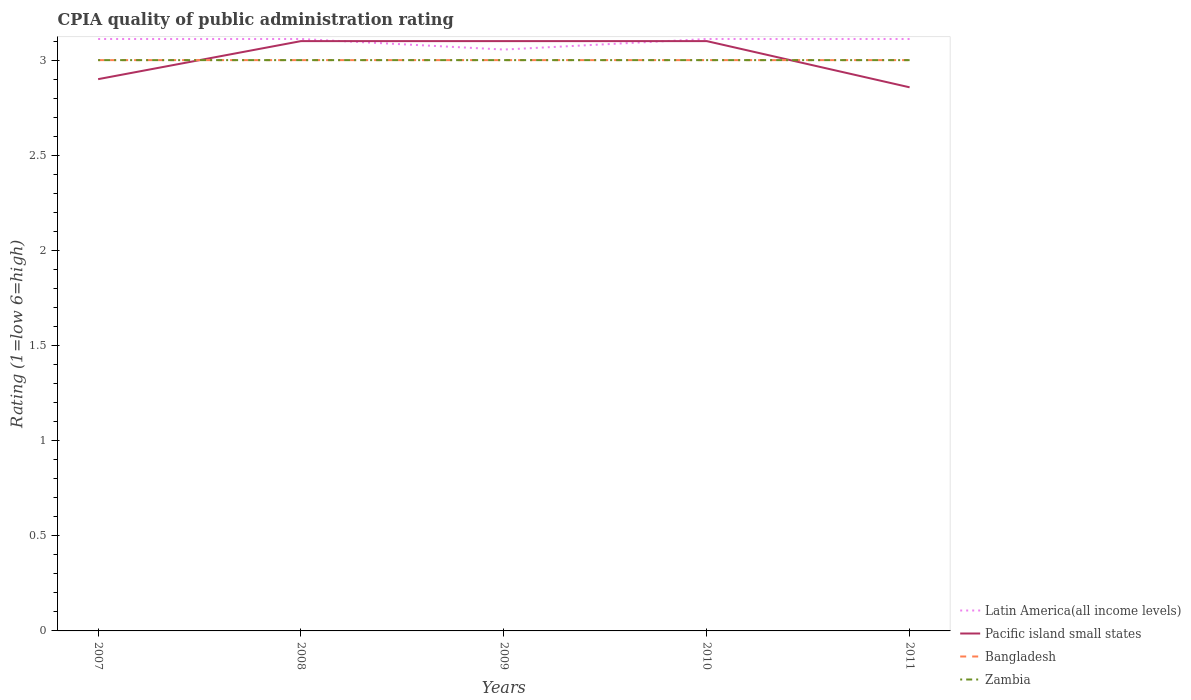How many different coloured lines are there?
Offer a very short reply. 4. Does the line corresponding to Pacific island small states intersect with the line corresponding to Latin America(all income levels)?
Provide a short and direct response. Yes. Across all years, what is the maximum CPIA rating in Latin America(all income levels)?
Give a very brief answer. 3.06. In which year was the CPIA rating in Zambia maximum?
Offer a very short reply. 2007. What is the difference between the highest and the lowest CPIA rating in Bangladesh?
Make the answer very short. 0. How many lines are there?
Offer a terse response. 4. How many years are there in the graph?
Your response must be concise. 5. What is the difference between two consecutive major ticks on the Y-axis?
Provide a short and direct response. 0.5. Does the graph contain any zero values?
Give a very brief answer. No. Does the graph contain grids?
Offer a very short reply. No. How many legend labels are there?
Ensure brevity in your answer.  4. What is the title of the graph?
Your answer should be compact. CPIA quality of public administration rating. Does "Zambia" appear as one of the legend labels in the graph?
Make the answer very short. Yes. What is the Rating (1=low 6=high) in Latin America(all income levels) in 2007?
Your answer should be very brief. 3.11. What is the Rating (1=low 6=high) of Pacific island small states in 2007?
Give a very brief answer. 2.9. What is the Rating (1=low 6=high) of Zambia in 2007?
Offer a very short reply. 3. What is the Rating (1=low 6=high) in Latin America(all income levels) in 2008?
Make the answer very short. 3.11. What is the Rating (1=low 6=high) of Latin America(all income levels) in 2009?
Give a very brief answer. 3.06. What is the Rating (1=low 6=high) in Pacific island small states in 2009?
Your response must be concise. 3.1. What is the Rating (1=low 6=high) of Bangladesh in 2009?
Provide a short and direct response. 3. What is the Rating (1=low 6=high) in Zambia in 2009?
Your answer should be compact. 3. What is the Rating (1=low 6=high) in Latin America(all income levels) in 2010?
Your response must be concise. 3.11. What is the Rating (1=low 6=high) of Bangladesh in 2010?
Give a very brief answer. 3. What is the Rating (1=low 6=high) in Zambia in 2010?
Your answer should be very brief. 3. What is the Rating (1=low 6=high) of Latin America(all income levels) in 2011?
Your answer should be very brief. 3.11. What is the Rating (1=low 6=high) of Pacific island small states in 2011?
Your answer should be very brief. 2.86. What is the Rating (1=low 6=high) in Bangladesh in 2011?
Your answer should be very brief. 3. What is the Rating (1=low 6=high) of Zambia in 2011?
Provide a short and direct response. 3. Across all years, what is the maximum Rating (1=low 6=high) in Latin America(all income levels)?
Provide a succinct answer. 3.11. Across all years, what is the maximum Rating (1=low 6=high) of Zambia?
Offer a terse response. 3. Across all years, what is the minimum Rating (1=low 6=high) in Latin America(all income levels)?
Your response must be concise. 3.06. Across all years, what is the minimum Rating (1=low 6=high) of Pacific island small states?
Provide a short and direct response. 2.86. What is the total Rating (1=low 6=high) of Pacific island small states in the graph?
Your answer should be compact. 15.06. What is the difference between the Rating (1=low 6=high) in Bangladesh in 2007 and that in 2008?
Your answer should be very brief. 0. What is the difference between the Rating (1=low 6=high) of Latin America(all income levels) in 2007 and that in 2009?
Your answer should be compact. 0.06. What is the difference between the Rating (1=low 6=high) of Pacific island small states in 2007 and that in 2009?
Give a very brief answer. -0.2. What is the difference between the Rating (1=low 6=high) of Bangladesh in 2007 and that in 2009?
Your response must be concise. 0. What is the difference between the Rating (1=low 6=high) of Latin America(all income levels) in 2007 and that in 2010?
Keep it short and to the point. 0. What is the difference between the Rating (1=low 6=high) of Pacific island small states in 2007 and that in 2010?
Keep it short and to the point. -0.2. What is the difference between the Rating (1=low 6=high) in Zambia in 2007 and that in 2010?
Ensure brevity in your answer.  0. What is the difference between the Rating (1=low 6=high) in Latin America(all income levels) in 2007 and that in 2011?
Your answer should be very brief. 0. What is the difference between the Rating (1=low 6=high) of Pacific island small states in 2007 and that in 2011?
Keep it short and to the point. 0.04. What is the difference between the Rating (1=low 6=high) in Zambia in 2007 and that in 2011?
Offer a terse response. 0. What is the difference between the Rating (1=low 6=high) in Latin America(all income levels) in 2008 and that in 2009?
Make the answer very short. 0.06. What is the difference between the Rating (1=low 6=high) in Pacific island small states in 2008 and that in 2009?
Keep it short and to the point. 0. What is the difference between the Rating (1=low 6=high) of Bangladesh in 2008 and that in 2009?
Your response must be concise. 0. What is the difference between the Rating (1=low 6=high) of Zambia in 2008 and that in 2010?
Your answer should be compact. 0. What is the difference between the Rating (1=low 6=high) of Pacific island small states in 2008 and that in 2011?
Give a very brief answer. 0.24. What is the difference between the Rating (1=low 6=high) of Latin America(all income levels) in 2009 and that in 2010?
Make the answer very short. -0.06. What is the difference between the Rating (1=low 6=high) in Zambia in 2009 and that in 2010?
Ensure brevity in your answer.  0. What is the difference between the Rating (1=low 6=high) of Latin America(all income levels) in 2009 and that in 2011?
Make the answer very short. -0.06. What is the difference between the Rating (1=low 6=high) of Pacific island small states in 2009 and that in 2011?
Offer a very short reply. 0.24. What is the difference between the Rating (1=low 6=high) in Pacific island small states in 2010 and that in 2011?
Provide a short and direct response. 0.24. What is the difference between the Rating (1=low 6=high) in Latin America(all income levels) in 2007 and the Rating (1=low 6=high) in Pacific island small states in 2008?
Your answer should be very brief. 0.01. What is the difference between the Rating (1=low 6=high) of Latin America(all income levels) in 2007 and the Rating (1=low 6=high) of Bangladesh in 2008?
Offer a very short reply. 0.11. What is the difference between the Rating (1=low 6=high) of Latin America(all income levels) in 2007 and the Rating (1=low 6=high) of Zambia in 2008?
Keep it short and to the point. 0.11. What is the difference between the Rating (1=low 6=high) of Pacific island small states in 2007 and the Rating (1=low 6=high) of Bangladesh in 2008?
Give a very brief answer. -0.1. What is the difference between the Rating (1=low 6=high) of Pacific island small states in 2007 and the Rating (1=low 6=high) of Zambia in 2008?
Provide a succinct answer. -0.1. What is the difference between the Rating (1=low 6=high) of Latin America(all income levels) in 2007 and the Rating (1=low 6=high) of Pacific island small states in 2009?
Make the answer very short. 0.01. What is the difference between the Rating (1=low 6=high) of Latin America(all income levels) in 2007 and the Rating (1=low 6=high) of Zambia in 2009?
Make the answer very short. 0.11. What is the difference between the Rating (1=low 6=high) of Pacific island small states in 2007 and the Rating (1=low 6=high) of Zambia in 2009?
Keep it short and to the point. -0.1. What is the difference between the Rating (1=low 6=high) of Bangladesh in 2007 and the Rating (1=low 6=high) of Zambia in 2009?
Offer a very short reply. 0. What is the difference between the Rating (1=low 6=high) in Latin America(all income levels) in 2007 and the Rating (1=low 6=high) in Pacific island small states in 2010?
Your answer should be very brief. 0.01. What is the difference between the Rating (1=low 6=high) in Latin America(all income levels) in 2007 and the Rating (1=low 6=high) in Bangladesh in 2010?
Provide a short and direct response. 0.11. What is the difference between the Rating (1=low 6=high) in Pacific island small states in 2007 and the Rating (1=low 6=high) in Bangladesh in 2010?
Your answer should be very brief. -0.1. What is the difference between the Rating (1=low 6=high) in Pacific island small states in 2007 and the Rating (1=low 6=high) in Zambia in 2010?
Your answer should be compact. -0.1. What is the difference between the Rating (1=low 6=high) of Latin America(all income levels) in 2007 and the Rating (1=low 6=high) of Pacific island small states in 2011?
Your answer should be compact. 0.25. What is the difference between the Rating (1=low 6=high) of Latin America(all income levels) in 2007 and the Rating (1=low 6=high) of Bangladesh in 2011?
Your response must be concise. 0.11. What is the difference between the Rating (1=low 6=high) in Latin America(all income levels) in 2007 and the Rating (1=low 6=high) in Zambia in 2011?
Your answer should be very brief. 0.11. What is the difference between the Rating (1=low 6=high) of Pacific island small states in 2007 and the Rating (1=low 6=high) of Zambia in 2011?
Your answer should be compact. -0.1. What is the difference between the Rating (1=low 6=high) of Latin America(all income levels) in 2008 and the Rating (1=low 6=high) of Pacific island small states in 2009?
Offer a very short reply. 0.01. What is the difference between the Rating (1=low 6=high) of Latin America(all income levels) in 2008 and the Rating (1=low 6=high) of Bangladesh in 2009?
Provide a succinct answer. 0.11. What is the difference between the Rating (1=low 6=high) in Pacific island small states in 2008 and the Rating (1=low 6=high) in Bangladesh in 2009?
Make the answer very short. 0.1. What is the difference between the Rating (1=low 6=high) in Bangladesh in 2008 and the Rating (1=low 6=high) in Zambia in 2009?
Provide a short and direct response. 0. What is the difference between the Rating (1=low 6=high) in Latin America(all income levels) in 2008 and the Rating (1=low 6=high) in Pacific island small states in 2010?
Make the answer very short. 0.01. What is the difference between the Rating (1=low 6=high) in Pacific island small states in 2008 and the Rating (1=low 6=high) in Zambia in 2010?
Make the answer very short. 0.1. What is the difference between the Rating (1=low 6=high) in Bangladesh in 2008 and the Rating (1=low 6=high) in Zambia in 2010?
Keep it short and to the point. 0. What is the difference between the Rating (1=low 6=high) of Latin America(all income levels) in 2008 and the Rating (1=low 6=high) of Pacific island small states in 2011?
Give a very brief answer. 0.25. What is the difference between the Rating (1=low 6=high) in Pacific island small states in 2008 and the Rating (1=low 6=high) in Zambia in 2011?
Your answer should be compact. 0.1. What is the difference between the Rating (1=low 6=high) of Latin America(all income levels) in 2009 and the Rating (1=low 6=high) of Pacific island small states in 2010?
Provide a short and direct response. -0.04. What is the difference between the Rating (1=low 6=high) of Latin America(all income levels) in 2009 and the Rating (1=low 6=high) of Bangladesh in 2010?
Ensure brevity in your answer.  0.06. What is the difference between the Rating (1=low 6=high) in Latin America(all income levels) in 2009 and the Rating (1=low 6=high) in Zambia in 2010?
Offer a very short reply. 0.06. What is the difference between the Rating (1=low 6=high) of Pacific island small states in 2009 and the Rating (1=low 6=high) of Bangladesh in 2010?
Provide a short and direct response. 0.1. What is the difference between the Rating (1=low 6=high) of Pacific island small states in 2009 and the Rating (1=low 6=high) of Zambia in 2010?
Keep it short and to the point. 0.1. What is the difference between the Rating (1=low 6=high) of Bangladesh in 2009 and the Rating (1=low 6=high) of Zambia in 2010?
Provide a succinct answer. 0. What is the difference between the Rating (1=low 6=high) in Latin America(all income levels) in 2009 and the Rating (1=low 6=high) in Pacific island small states in 2011?
Make the answer very short. 0.2. What is the difference between the Rating (1=low 6=high) of Latin America(all income levels) in 2009 and the Rating (1=low 6=high) of Bangladesh in 2011?
Offer a terse response. 0.06. What is the difference between the Rating (1=low 6=high) of Latin America(all income levels) in 2009 and the Rating (1=low 6=high) of Zambia in 2011?
Make the answer very short. 0.06. What is the difference between the Rating (1=low 6=high) of Pacific island small states in 2009 and the Rating (1=low 6=high) of Bangladesh in 2011?
Provide a short and direct response. 0.1. What is the difference between the Rating (1=low 6=high) in Pacific island small states in 2009 and the Rating (1=low 6=high) in Zambia in 2011?
Your answer should be compact. 0.1. What is the difference between the Rating (1=low 6=high) of Latin America(all income levels) in 2010 and the Rating (1=low 6=high) of Pacific island small states in 2011?
Your answer should be very brief. 0.25. What is the difference between the Rating (1=low 6=high) in Latin America(all income levels) in 2010 and the Rating (1=low 6=high) in Bangladesh in 2011?
Provide a short and direct response. 0.11. What is the difference between the Rating (1=low 6=high) in Latin America(all income levels) in 2010 and the Rating (1=low 6=high) in Zambia in 2011?
Your answer should be very brief. 0.11. What is the difference between the Rating (1=low 6=high) in Pacific island small states in 2010 and the Rating (1=low 6=high) in Bangladesh in 2011?
Offer a terse response. 0.1. What is the difference between the Rating (1=low 6=high) of Pacific island small states in 2010 and the Rating (1=low 6=high) of Zambia in 2011?
Your answer should be very brief. 0.1. What is the difference between the Rating (1=low 6=high) of Bangladesh in 2010 and the Rating (1=low 6=high) of Zambia in 2011?
Provide a short and direct response. 0. What is the average Rating (1=low 6=high) in Pacific island small states per year?
Keep it short and to the point. 3.01. In the year 2007, what is the difference between the Rating (1=low 6=high) in Latin America(all income levels) and Rating (1=low 6=high) in Pacific island small states?
Your answer should be very brief. 0.21. In the year 2007, what is the difference between the Rating (1=low 6=high) in Latin America(all income levels) and Rating (1=low 6=high) in Zambia?
Provide a succinct answer. 0.11. In the year 2007, what is the difference between the Rating (1=low 6=high) of Pacific island small states and Rating (1=low 6=high) of Bangladesh?
Your answer should be very brief. -0.1. In the year 2007, what is the difference between the Rating (1=low 6=high) in Bangladesh and Rating (1=low 6=high) in Zambia?
Make the answer very short. 0. In the year 2008, what is the difference between the Rating (1=low 6=high) of Latin America(all income levels) and Rating (1=low 6=high) of Pacific island small states?
Your answer should be very brief. 0.01. In the year 2008, what is the difference between the Rating (1=low 6=high) in Latin America(all income levels) and Rating (1=low 6=high) in Bangladesh?
Give a very brief answer. 0.11. In the year 2008, what is the difference between the Rating (1=low 6=high) in Latin America(all income levels) and Rating (1=low 6=high) in Zambia?
Offer a terse response. 0.11. In the year 2008, what is the difference between the Rating (1=low 6=high) in Pacific island small states and Rating (1=low 6=high) in Bangladesh?
Offer a very short reply. 0.1. In the year 2008, what is the difference between the Rating (1=low 6=high) of Pacific island small states and Rating (1=low 6=high) of Zambia?
Offer a very short reply. 0.1. In the year 2009, what is the difference between the Rating (1=low 6=high) in Latin America(all income levels) and Rating (1=low 6=high) in Pacific island small states?
Provide a succinct answer. -0.04. In the year 2009, what is the difference between the Rating (1=low 6=high) of Latin America(all income levels) and Rating (1=low 6=high) of Bangladesh?
Give a very brief answer. 0.06. In the year 2009, what is the difference between the Rating (1=low 6=high) in Latin America(all income levels) and Rating (1=low 6=high) in Zambia?
Your answer should be compact. 0.06. In the year 2009, what is the difference between the Rating (1=low 6=high) of Pacific island small states and Rating (1=low 6=high) of Bangladesh?
Give a very brief answer. 0.1. In the year 2009, what is the difference between the Rating (1=low 6=high) of Bangladesh and Rating (1=low 6=high) of Zambia?
Give a very brief answer. 0. In the year 2010, what is the difference between the Rating (1=low 6=high) in Latin America(all income levels) and Rating (1=low 6=high) in Pacific island small states?
Offer a very short reply. 0.01. In the year 2010, what is the difference between the Rating (1=low 6=high) of Latin America(all income levels) and Rating (1=low 6=high) of Zambia?
Your answer should be very brief. 0.11. In the year 2010, what is the difference between the Rating (1=low 6=high) of Pacific island small states and Rating (1=low 6=high) of Bangladesh?
Keep it short and to the point. 0.1. In the year 2010, what is the difference between the Rating (1=low 6=high) of Pacific island small states and Rating (1=low 6=high) of Zambia?
Your answer should be very brief. 0.1. In the year 2011, what is the difference between the Rating (1=low 6=high) of Latin America(all income levels) and Rating (1=low 6=high) of Pacific island small states?
Ensure brevity in your answer.  0.25. In the year 2011, what is the difference between the Rating (1=low 6=high) in Latin America(all income levels) and Rating (1=low 6=high) in Bangladesh?
Give a very brief answer. 0.11. In the year 2011, what is the difference between the Rating (1=low 6=high) in Pacific island small states and Rating (1=low 6=high) in Bangladesh?
Give a very brief answer. -0.14. In the year 2011, what is the difference between the Rating (1=low 6=high) in Pacific island small states and Rating (1=low 6=high) in Zambia?
Your answer should be compact. -0.14. What is the ratio of the Rating (1=low 6=high) in Pacific island small states in 2007 to that in 2008?
Ensure brevity in your answer.  0.94. What is the ratio of the Rating (1=low 6=high) in Bangladesh in 2007 to that in 2008?
Provide a short and direct response. 1. What is the ratio of the Rating (1=low 6=high) of Zambia in 2007 to that in 2008?
Your answer should be very brief. 1. What is the ratio of the Rating (1=low 6=high) in Latin America(all income levels) in 2007 to that in 2009?
Keep it short and to the point. 1.02. What is the ratio of the Rating (1=low 6=high) of Pacific island small states in 2007 to that in 2009?
Give a very brief answer. 0.94. What is the ratio of the Rating (1=low 6=high) of Zambia in 2007 to that in 2009?
Ensure brevity in your answer.  1. What is the ratio of the Rating (1=low 6=high) in Latin America(all income levels) in 2007 to that in 2010?
Give a very brief answer. 1. What is the ratio of the Rating (1=low 6=high) in Pacific island small states in 2007 to that in 2010?
Provide a succinct answer. 0.94. What is the ratio of the Rating (1=low 6=high) in Zambia in 2007 to that in 2010?
Your answer should be very brief. 1. What is the ratio of the Rating (1=low 6=high) of Bangladesh in 2007 to that in 2011?
Your response must be concise. 1. What is the ratio of the Rating (1=low 6=high) of Latin America(all income levels) in 2008 to that in 2009?
Make the answer very short. 1.02. What is the ratio of the Rating (1=low 6=high) in Pacific island small states in 2008 to that in 2009?
Provide a succinct answer. 1. What is the ratio of the Rating (1=low 6=high) of Bangladesh in 2008 to that in 2009?
Ensure brevity in your answer.  1. What is the ratio of the Rating (1=low 6=high) in Latin America(all income levels) in 2008 to that in 2011?
Your answer should be compact. 1. What is the ratio of the Rating (1=low 6=high) of Pacific island small states in 2008 to that in 2011?
Offer a terse response. 1.08. What is the ratio of the Rating (1=low 6=high) in Zambia in 2008 to that in 2011?
Ensure brevity in your answer.  1. What is the ratio of the Rating (1=low 6=high) of Latin America(all income levels) in 2009 to that in 2010?
Your response must be concise. 0.98. What is the ratio of the Rating (1=low 6=high) in Pacific island small states in 2009 to that in 2010?
Offer a terse response. 1. What is the ratio of the Rating (1=low 6=high) of Bangladesh in 2009 to that in 2010?
Provide a short and direct response. 1. What is the ratio of the Rating (1=low 6=high) in Zambia in 2009 to that in 2010?
Provide a succinct answer. 1. What is the ratio of the Rating (1=low 6=high) of Latin America(all income levels) in 2009 to that in 2011?
Your answer should be very brief. 0.98. What is the ratio of the Rating (1=low 6=high) in Pacific island small states in 2009 to that in 2011?
Keep it short and to the point. 1.08. What is the ratio of the Rating (1=low 6=high) in Bangladesh in 2009 to that in 2011?
Your answer should be very brief. 1. What is the ratio of the Rating (1=low 6=high) of Pacific island small states in 2010 to that in 2011?
Provide a short and direct response. 1.08. What is the ratio of the Rating (1=low 6=high) of Zambia in 2010 to that in 2011?
Give a very brief answer. 1. What is the difference between the highest and the second highest Rating (1=low 6=high) of Latin America(all income levels)?
Keep it short and to the point. 0. What is the difference between the highest and the second highest Rating (1=low 6=high) in Pacific island small states?
Keep it short and to the point. 0. What is the difference between the highest and the second highest Rating (1=low 6=high) of Bangladesh?
Offer a very short reply. 0. What is the difference between the highest and the second highest Rating (1=low 6=high) of Zambia?
Provide a short and direct response. 0. What is the difference between the highest and the lowest Rating (1=low 6=high) of Latin America(all income levels)?
Keep it short and to the point. 0.06. What is the difference between the highest and the lowest Rating (1=low 6=high) in Pacific island small states?
Provide a succinct answer. 0.24. 